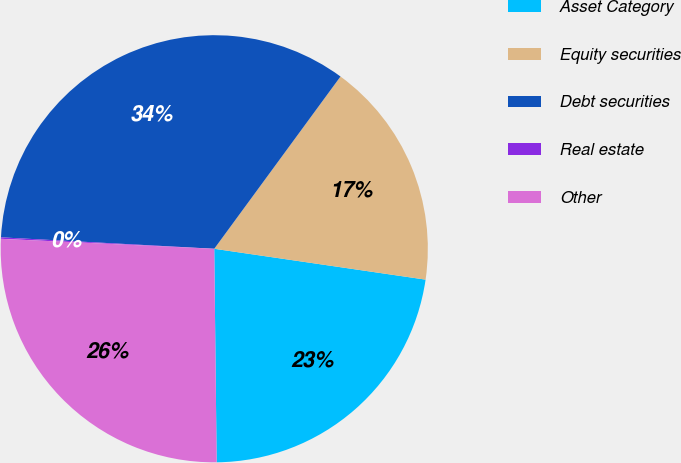Convert chart to OTSL. <chart><loc_0><loc_0><loc_500><loc_500><pie_chart><fcel>Asset Category<fcel>Equity securities<fcel>Debt securities<fcel>Real estate<fcel>Other<nl><fcel>22.51%<fcel>17.24%<fcel>34.21%<fcel>0.11%<fcel>25.92%<nl></chart> 